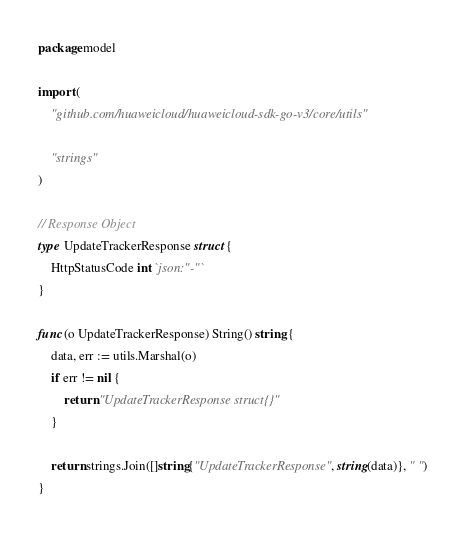<code> <loc_0><loc_0><loc_500><loc_500><_Go_>package model

import (
	"github.com/huaweicloud/huaweicloud-sdk-go-v3/core/utils"

	"strings"
)

// Response Object
type UpdateTrackerResponse struct {
	HttpStatusCode int `json:"-"`
}

func (o UpdateTrackerResponse) String() string {
	data, err := utils.Marshal(o)
	if err != nil {
		return "UpdateTrackerResponse struct{}"
	}

	return strings.Join([]string{"UpdateTrackerResponse", string(data)}, " ")
}
</code> 